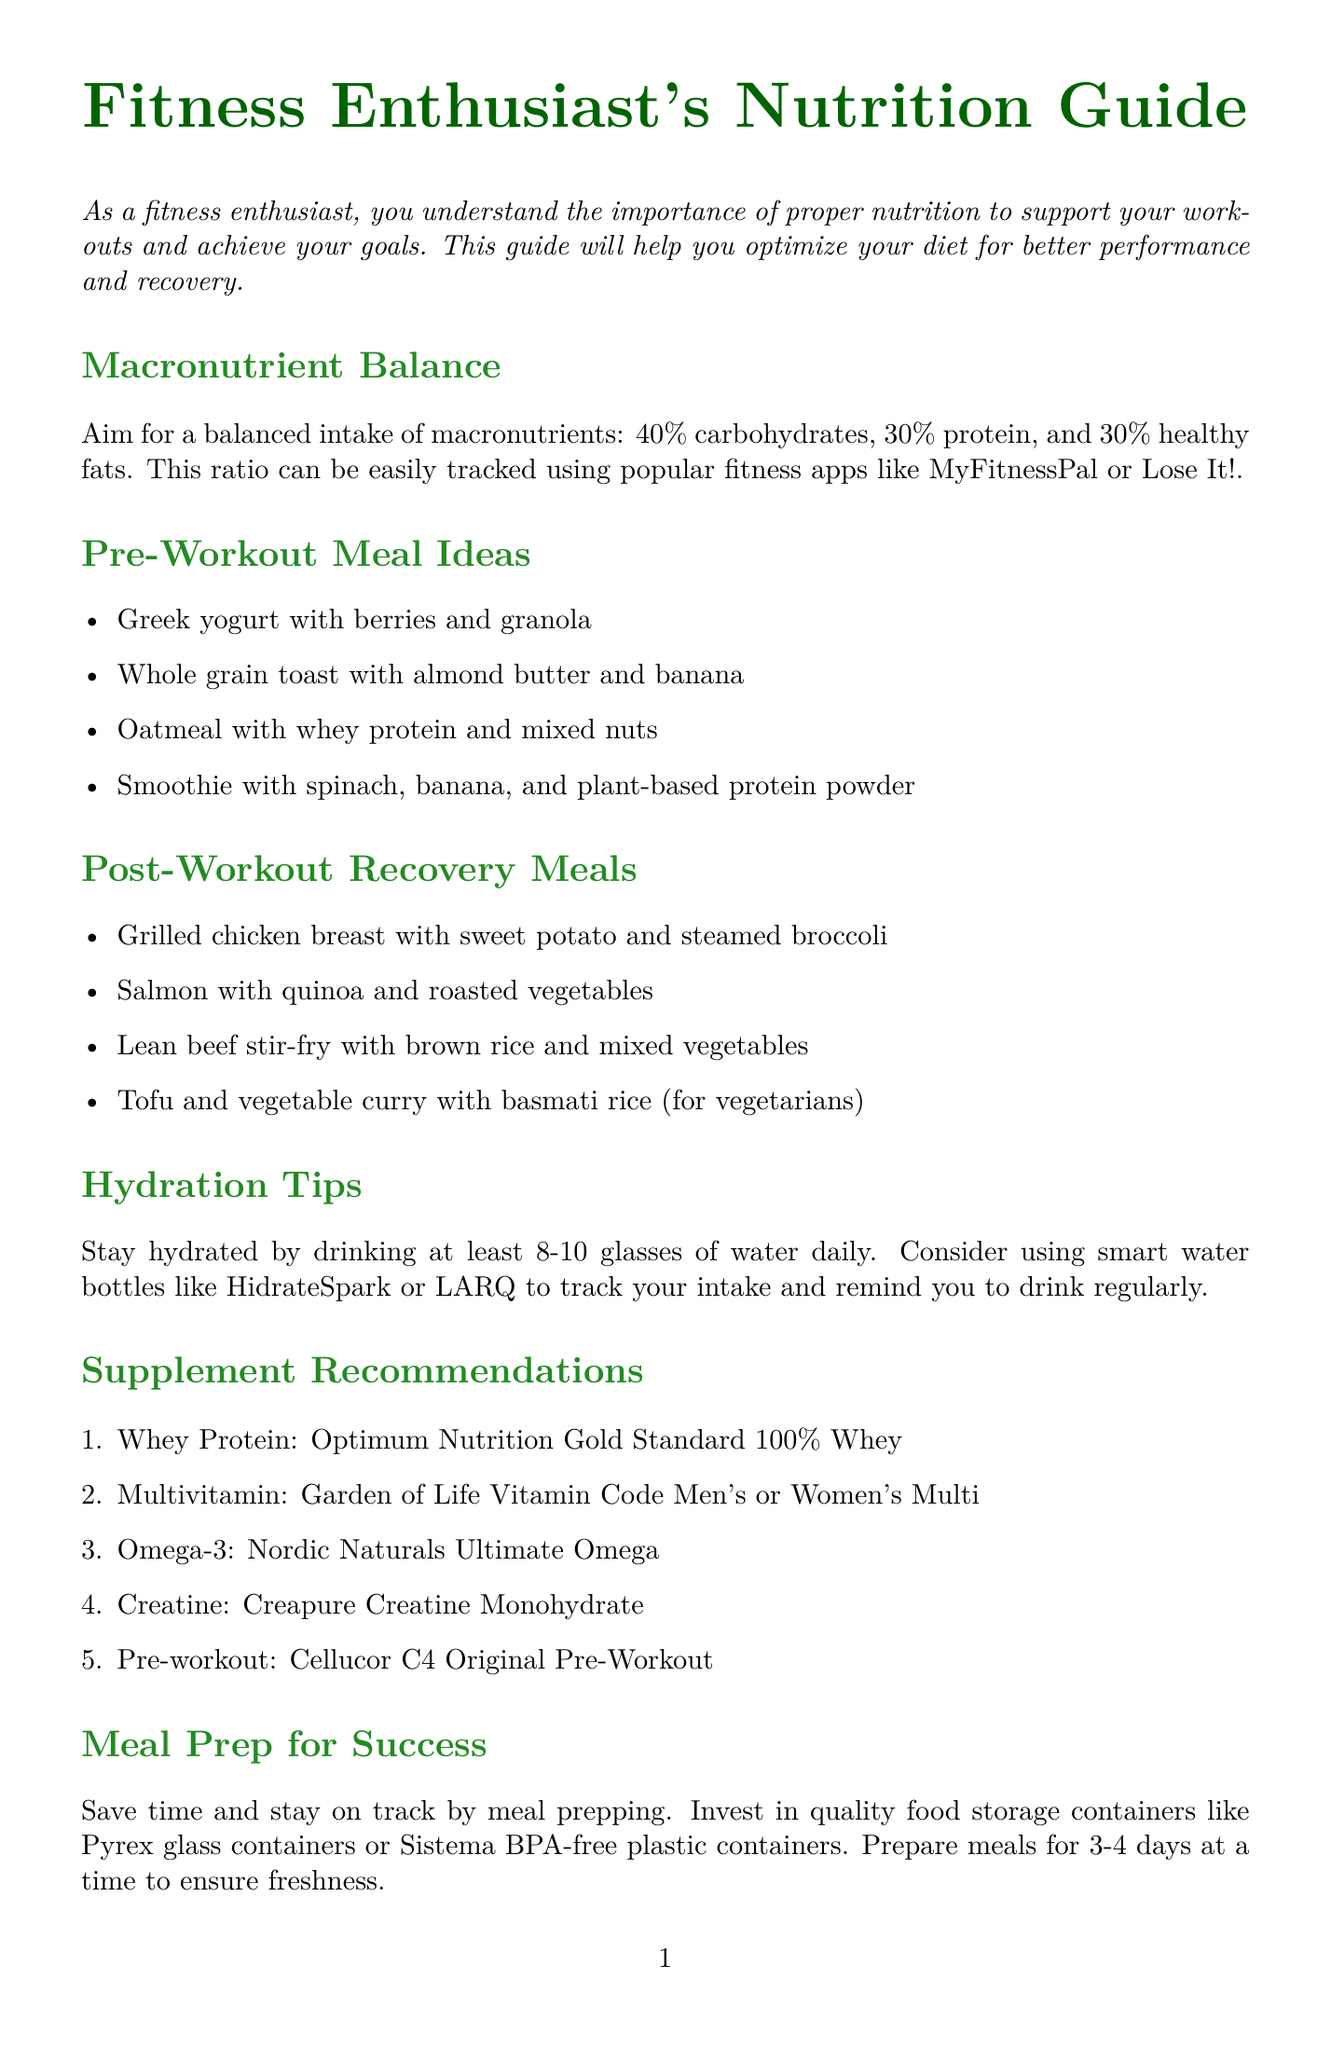what is the ideal macronutrient ratio for fitness enthusiasts? The document states to aim for a balanced intake of macronutrients: 40% carbohydrates, 30% protein, and 30% healthy fats.
Answer: 40% carbohydrates, 30% protein, 30% healthy fats name one pre-workout meal idea. The document lists several pre-workout meal ideas, including Greek yogurt with berries and granola.
Answer: Greek yogurt with berries and granola how many glasses of water should you drink daily? The hydration tips section recommends drinking at least 8-10 glasses of water daily.
Answer: 8-10 glasses which brand is recommended for omega-3 supplements? The supplement recommendations section mentions Nordic Naturals Ultimate Omega as a recommended omega-3 supplement.
Answer: Nordic Naturals Ultimate Omega what is one benefit of meal prepping? The document notes that meal prepping helps save time and stay on track with nutrition goals.
Answer: Save time name a technology that can track daily calorie burn. The document mentions Fitbit Charge 5 as a fitness tracker that can monitor daily calorie burn.
Answer: Fitbit Charge 5 what is a mindful eating practice suggested in the document? The document encourages practicing mindful eating by using smaller plates.
Answer: Using smaller plates list one nutrition resource provided in the newsletter. The nutrition resources section provides a book: 'The New Rules of Lifting for Life' by Lou Schuler and Alwyn Cosgrove.
Answer: 'The New Rules of Lifting for Life' by Lou Schuler and Alwyn Cosgrove 